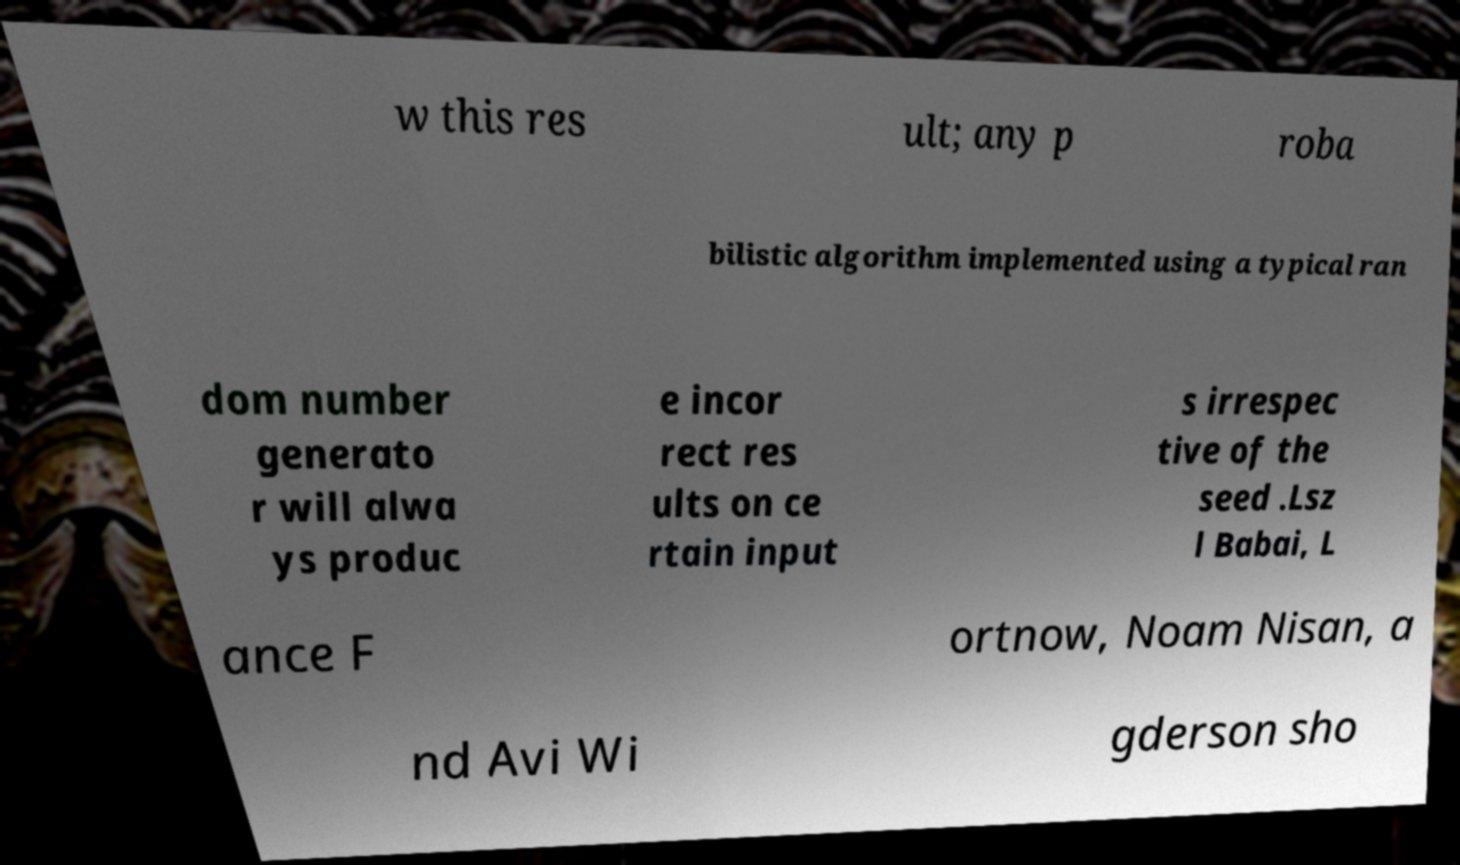There's text embedded in this image that I need extracted. Can you transcribe it verbatim? w this res ult; any p roba bilistic algorithm implemented using a typical ran dom number generato r will alwa ys produc e incor rect res ults on ce rtain input s irrespec tive of the seed .Lsz l Babai, L ance F ortnow, Noam Nisan, a nd Avi Wi gderson sho 